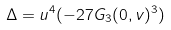<formula> <loc_0><loc_0><loc_500><loc_500>\Delta = u ^ { 4 } ( - 2 7 G _ { 3 } ( 0 , v ) ^ { 3 } )</formula> 